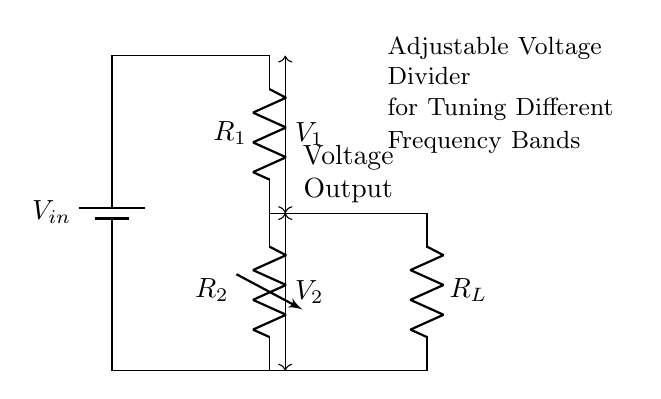What is the input voltage in this circuit? The circuit diagram shows a battery labeled as 'Vin,' which represents the input voltage supplied to the voltage divider.
Answer: Vin What are the resistances present in the circuit? The circuit contains two resistors: R1 and R2, with R2 being a variable resistor used to adjust the output voltage.
Answer: R1 and R2 What is the purpose of the variable resistor in this circuit? The variable resistor (R2) allows for adjustment of the voltage output (V2), which is essential for tuning different frequency bands in the vintage radio equipment.
Answer: Voltage tuning How does the voltage output relate to the resistances? According to the voltage divider rule, the output voltage (V2) can be calculated as V2 = Vin * (R2/(R1 + R2)), demonstrating how the resistances affect the output voltage.
Answer: Via the voltage divider rule What is the output voltage across R2 labeled as? The output voltage across R2 is labeled as 'V2' in the circuit diagram, indicating the voltage drop across the resistor it's connected to.
Answer: V2 How do you determine the total resistance in this circuit? The total resistance in the circuit is found by adding the values of R1 and R2 because they are in series: R_total = R1 + R2. To calculate the effective total resistance used in this circuit configuration, the adjustment of R2 impacts the total resistance seen by the input voltage.
Answer: R1 + R2 